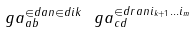Convert formula to latex. <formula><loc_0><loc_0><loc_500><loc_500>\ g a ^ { \in d { a } { n } \in d { i } { k } } _ { a b } \ g a ^ { \in d r { a } { n } i _ { k + 1 } \dots i _ { m } } _ { c d }</formula> 